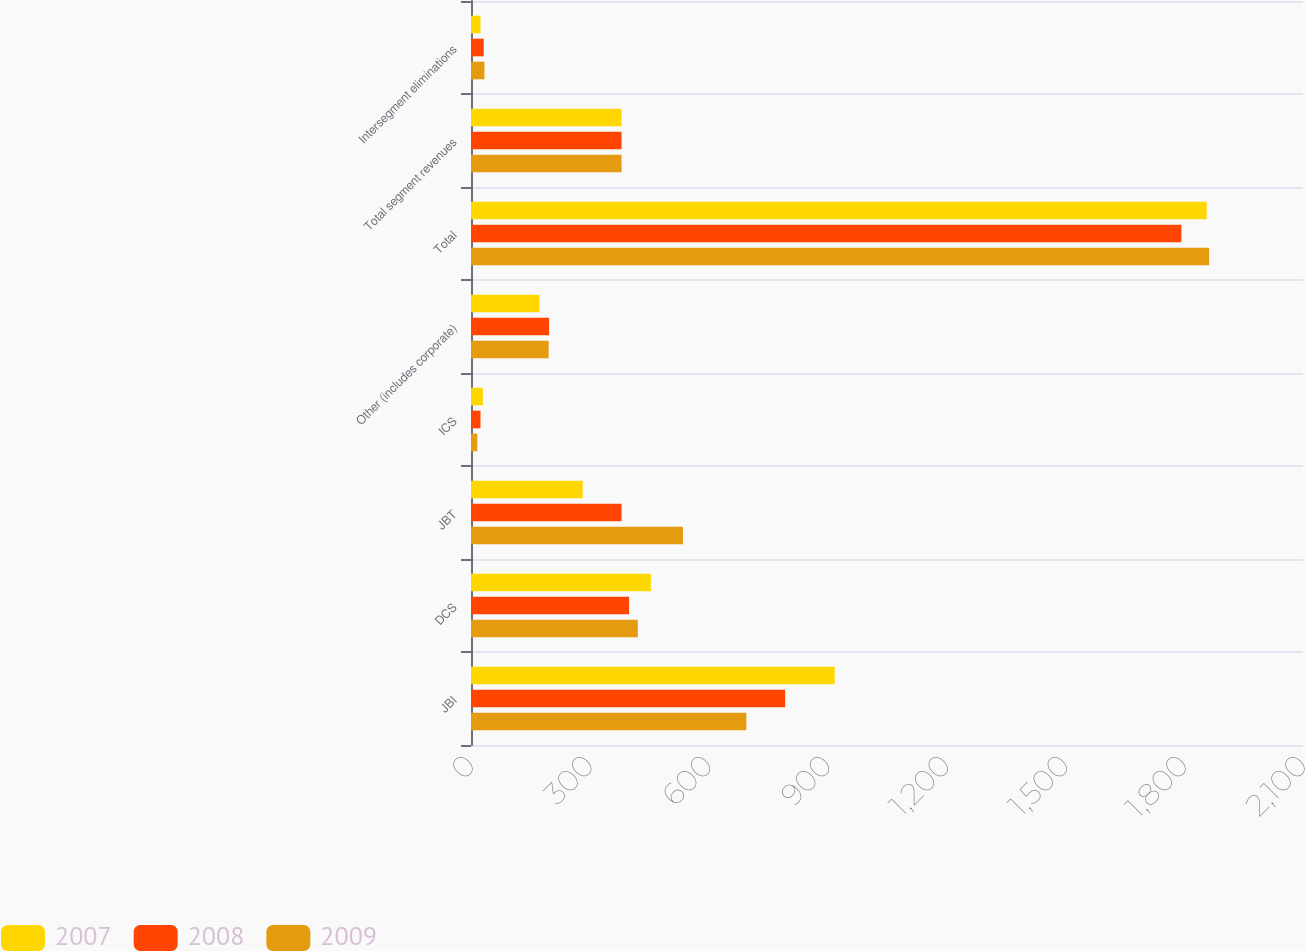<chart> <loc_0><loc_0><loc_500><loc_500><stacked_bar_chart><ecel><fcel>JBI<fcel>DCS<fcel>JBT<fcel>ICS<fcel>Other (includes corporate)<fcel>Total<fcel>Total segment revenues<fcel>Intersegment eliminations<nl><fcel>2007<fcel>918<fcel>454<fcel>282<fcel>30<fcel>173<fcel>1857<fcel>380<fcel>24<nl><fcel>2008<fcel>793<fcel>399<fcel>380<fcel>24<fcel>197<fcel>1793<fcel>380<fcel>32<nl><fcel>2009<fcel>695<fcel>421<fcel>535<fcel>16<fcel>196<fcel>1863<fcel>380<fcel>34<nl></chart> 